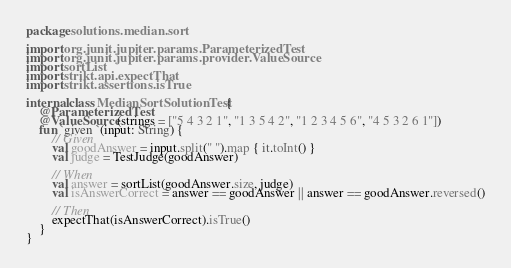Convert code to text. <code><loc_0><loc_0><loc_500><loc_500><_Kotlin_>package solutions.median.sort

import org.junit.jupiter.params.ParameterizedTest
import org.junit.jupiter.params.provider.ValueSource
import sortList
import strikt.api.expectThat
import strikt.assertions.isTrue

internal class MedianSortSolutionTest {
    @ParameterizedTest
    @ValueSource(strings = ["5 4 3 2 1", "1 3 5 4 2", "1 2 3 4 5 6", "4 5 3 2 6 1"])
    fun `given `(input: String) {
        // Given
        val goodAnswer = input.split(" ").map { it.toInt() }
        val judge = TestJudge(goodAnswer)

        // When
        val answer = sortList(goodAnswer.size, judge)
        val isAnswerCorrect = answer == goodAnswer || answer == goodAnswer.reversed()

        // Then
        expectThat(isAnswerCorrect).isTrue()
    }
}</code> 